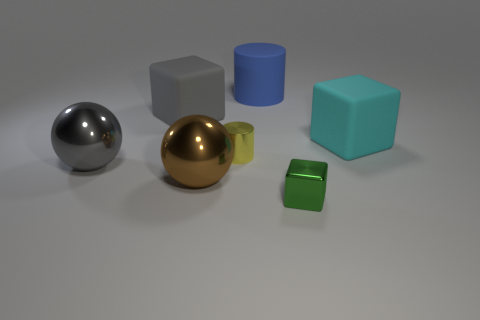What material is the big cube that is behind the cyan thing? rubber 